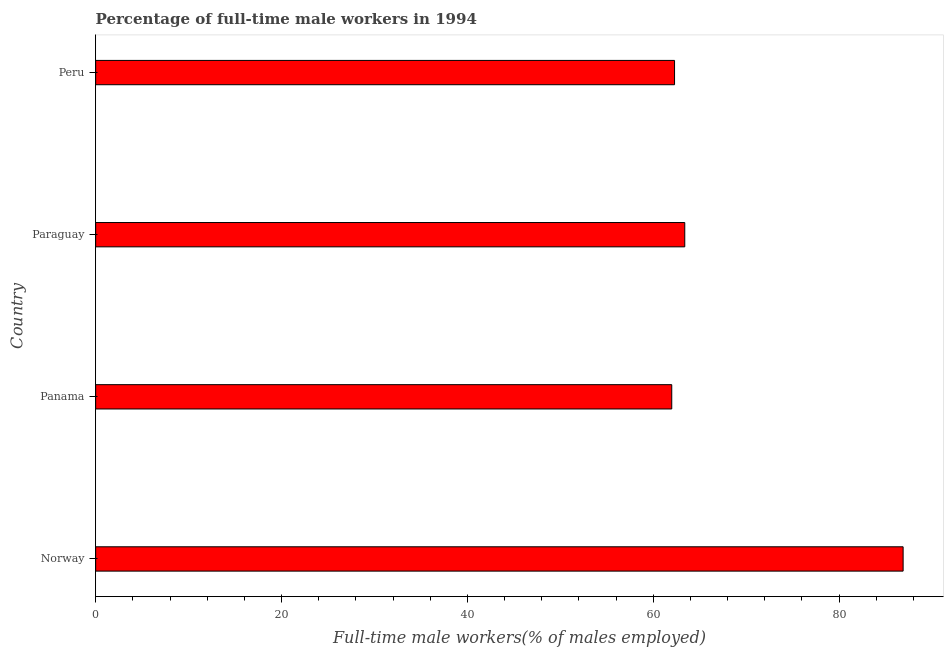What is the title of the graph?
Keep it short and to the point. Percentage of full-time male workers in 1994. What is the label or title of the X-axis?
Your response must be concise. Full-time male workers(% of males employed). What is the percentage of full-time male workers in Peru?
Your answer should be very brief. 62.3. Across all countries, what is the maximum percentage of full-time male workers?
Give a very brief answer. 86.9. In which country was the percentage of full-time male workers maximum?
Ensure brevity in your answer.  Norway. In which country was the percentage of full-time male workers minimum?
Your response must be concise. Panama. What is the sum of the percentage of full-time male workers?
Provide a succinct answer. 274.6. What is the difference between the percentage of full-time male workers in Norway and Panama?
Your answer should be compact. 24.9. What is the average percentage of full-time male workers per country?
Provide a succinct answer. 68.65. What is the median percentage of full-time male workers?
Give a very brief answer. 62.85. What is the ratio of the percentage of full-time male workers in Norway to that in Peru?
Offer a terse response. 1.4. Is the percentage of full-time male workers in Panama less than that in Peru?
Your answer should be very brief. Yes. Is the difference between the percentage of full-time male workers in Norway and Paraguay greater than the difference between any two countries?
Your answer should be very brief. No. What is the difference between the highest and the lowest percentage of full-time male workers?
Offer a very short reply. 24.9. In how many countries, is the percentage of full-time male workers greater than the average percentage of full-time male workers taken over all countries?
Your response must be concise. 1. How many countries are there in the graph?
Ensure brevity in your answer.  4. Are the values on the major ticks of X-axis written in scientific E-notation?
Give a very brief answer. No. What is the Full-time male workers(% of males employed) in Norway?
Keep it short and to the point. 86.9. What is the Full-time male workers(% of males employed) of Paraguay?
Offer a terse response. 63.4. What is the Full-time male workers(% of males employed) of Peru?
Offer a terse response. 62.3. What is the difference between the Full-time male workers(% of males employed) in Norway and Panama?
Give a very brief answer. 24.9. What is the difference between the Full-time male workers(% of males employed) in Norway and Paraguay?
Give a very brief answer. 23.5. What is the difference between the Full-time male workers(% of males employed) in Norway and Peru?
Ensure brevity in your answer.  24.6. What is the difference between the Full-time male workers(% of males employed) in Panama and Paraguay?
Provide a succinct answer. -1.4. What is the difference between the Full-time male workers(% of males employed) in Panama and Peru?
Your answer should be very brief. -0.3. What is the difference between the Full-time male workers(% of males employed) in Paraguay and Peru?
Provide a short and direct response. 1.1. What is the ratio of the Full-time male workers(% of males employed) in Norway to that in Panama?
Your answer should be very brief. 1.4. What is the ratio of the Full-time male workers(% of males employed) in Norway to that in Paraguay?
Make the answer very short. 1.37. What is the ratio of the Full-time male workers(% of males employed) in Norway to that in Peru?
Give a very brief answer. 1.4. What is the ratio of the Full-time male workers(% of males employed) in Panama to that in Paraguay?
Make the answer very short. 0.98. What is the ratio of the Full-time male workers(% of males employed) in Panama to that in Peru?
Provide a succinct answer. 0.99. 